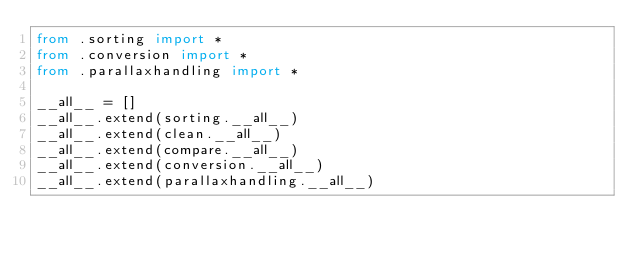<code> <loc_0><loc_0><loc_500><loc_500><_Python_>from .sorting import *
from .conversion import *
from .parallaxhandling import *

__all__ = []
__all__.extend(sorting.__all__)
__all__.extend(clean.__all__)
__all__.extend(compare.__all__)
__all__.extend(conversion.__all__)
__all__.extend(parallaxhandling.__all__)
</code> 